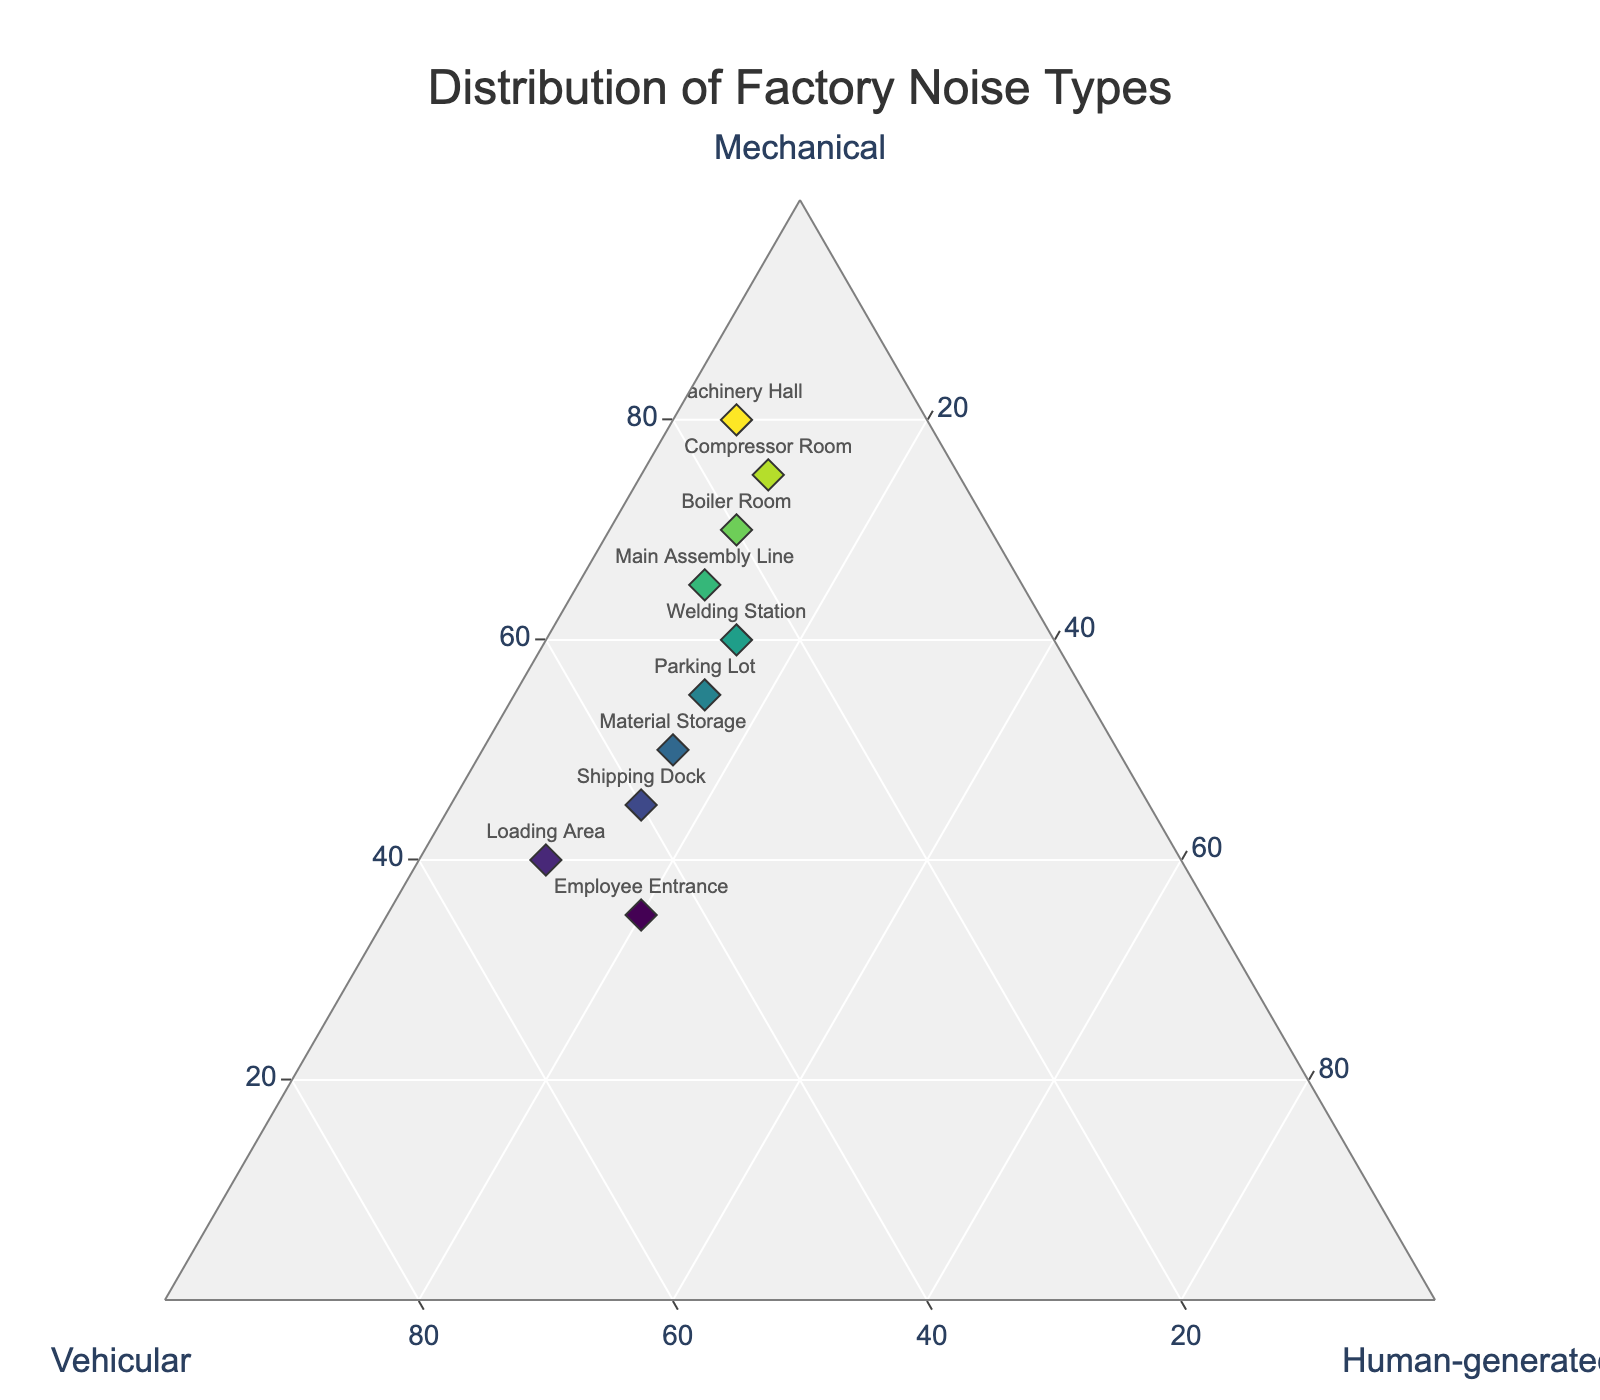What's the title of the figure? The title is usually displayed at the top of the figure. In this case, it is centered and says "Distribution of Factory Noise Types".
Answer: Distribution of Factory Noise Types How many data points are shown in the figure? Count each marker with text labels. There are 10 distinct locations, so there are 10 data points.
Answer: 10 Which location has the highest percentage of mechanical noise? Look for the data point with the highest value on the 'Mechanical' axis. Machinery Hall has 80% mechanical noise, the highest in the figure.
Answer: Machinery Hall Which location has the lowest percentage of human-generated noise? Check the 'Human-generated' axis for the smallest value. Machinery Hall has 5%, the lowest percentage of human-generated noise.
Answer: Machinery Hall What are the noise type percentages for Parking Lot? The figure will have the data with the label 'Parking Lot'. Parking Lot has 55% mechanical, 30% vehicular, and 15% human-generated noise.
Answer: 55% mechanical, 30% vehicular, 15% human-generated What is the total percentage of mechanical and vehicular noise at the Main Assembly Line? Sum up the percentages of mechanical and vehicular noise at the Main Assembly Line. It is 65% + 25% = 90%.
Answer: 90% Is the mechanical noise at the Boiler Room greater than the vehicular noise at the Shipping Dock? Compare the two values. The Boiler Room has 70% mechanical noise, and the Shipping Dock has 40% vehicular noise. Since 70% > 40%, the answer is yes.
Answer: Yes What is the average percentage of human-generated noise across all locations? Sum up the human-generated percentages from all locations and divide by the number of locations (10). (10+15+10+15+5+10+15+15+10+20) = 125. Average is 125 / 10 = 12.5%.
Answer: 12.5% Which location has the most balanced noise distribution in terms of mechanical, vehicular, and human-generated noise? Look for the data point where the percentages are roughly similar. 'Employee Entrance' has 35% mechanical, 45% vehicular, and 20% human-generated noise, which is the most balanced among all points shown.
Answer: Employee Entrance What is the difference in mechanical noise between Compressor Room and Boiler Room? Subtract the percentage values of mechanical noise for these two locations. Compressor Room has 75% and Boiler Room has 70%. The difference is 75% - 70% = 5%.
Answer: 5% 